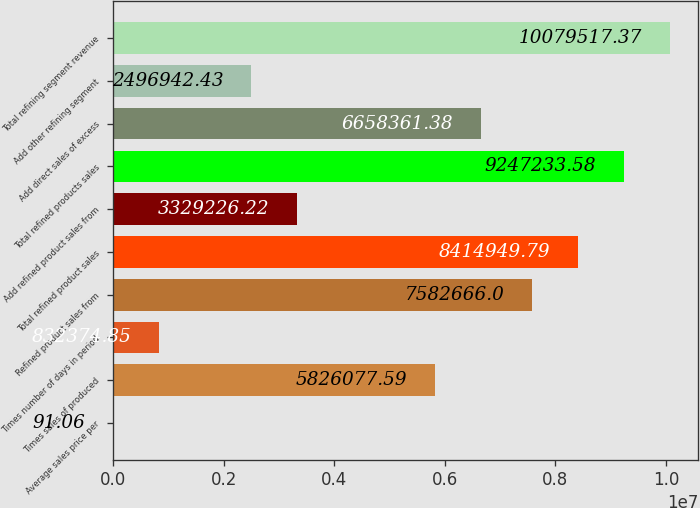Convert chart. <chart><loc_0><loc_0><loc_500><loc_500><bar_chart><fcel>Average sales price per<fcel>Times sales of produced<fcel>Times number of days in period<fcel>Refined product sales from<fcel>Total refined product sales<fcel>Add refined product sales from<fcel>Total refined products sales<fcel>Add direct sales of excess<fcel>Add other refining segment<fcel>Total refining segment revenue<nl><fcel>91.06<fcel>5.82608e+06<fcel>832375<fcel>7.58267e+06<fcel>8.41495e+06<fcel>3.32923e+06<fcel>9.24723e+06<fcel>6.65836e+06<fcel>2.49694e+06<fcel>1.00795e+07<nl></chart> 